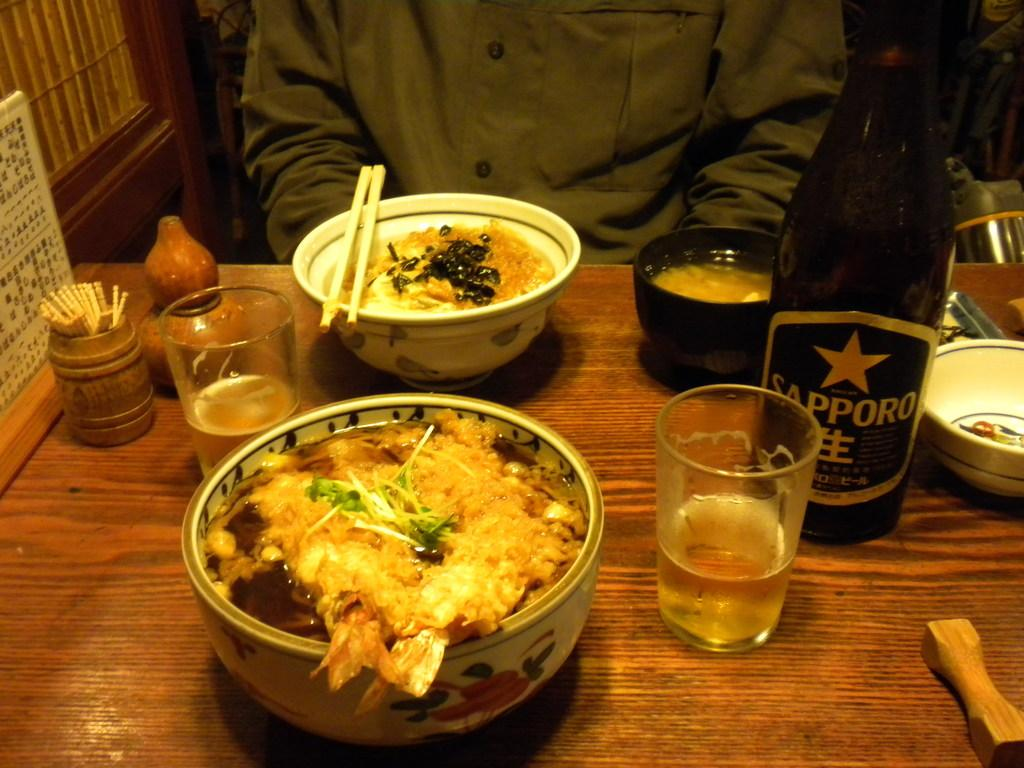What is present on the table in the image? There are food items and objects on the table in the image. Can you describe the person visible behind the table? There is a person visible behind the table in the image, but no specific details about their appearance or actions are provided. What type of object is located in the top left of the image? There is a wooden object in the top left of the image. What type of fiction is the donkey reading in the image? There is no donkey or any reading material present in the image. What is the person behind the table afraid of in the image? There is no indication of fear or any specific emotions in the image. 